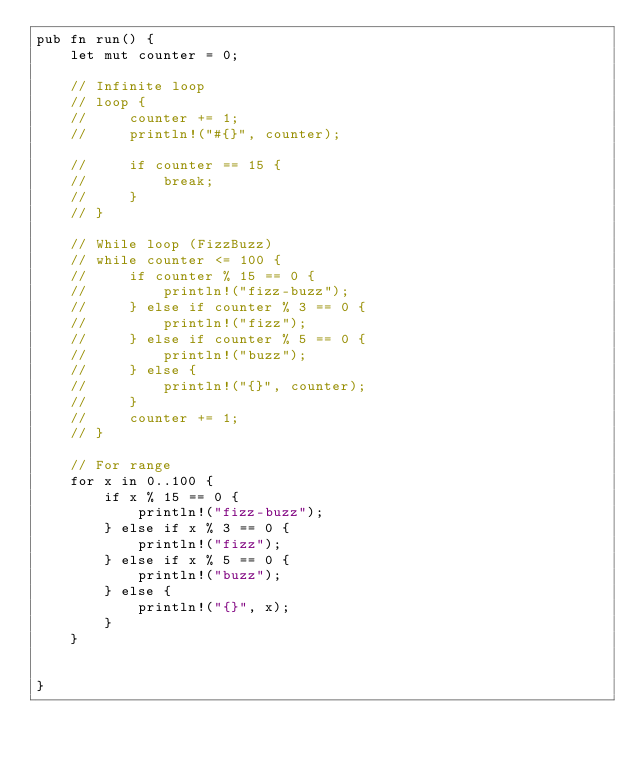<code> <loc_0><loc_0><loc_500><loc_500><_Rust_>pub fn run() {
    let mut counter = 0;

    // Infinite loop
    // loop {
    //     counter += 1;
    //     println!("#{}", counter);

    //     if counter == 15 {
    //         break;
    //     }
    // }

    // While loop (FizzBuzz)
    // while counter <= 100 {
    //     if counter % 15 == 0 {
    //         println!("fizz-buzz");
    //     } else if counter % 3 == 0 {
    //         println!("fizz");
    //     } else if counter % 5 == 0 {
    //         println!("buzz");
    //     } else {
    //         println!("{}", counter);
    //     }
    //     counter += 1;
    // }

    // For range
    for x in 0..100 {
        if x % 15 == 0 {
            println!("fizz-buzz");
        } else if x % 3 == 0 {
            println!("fizz");
        } else if x % 5 == 0 {
            println!("buzz");
        } else {
            println!("{}", x);
        }
    }

    
}</code> 